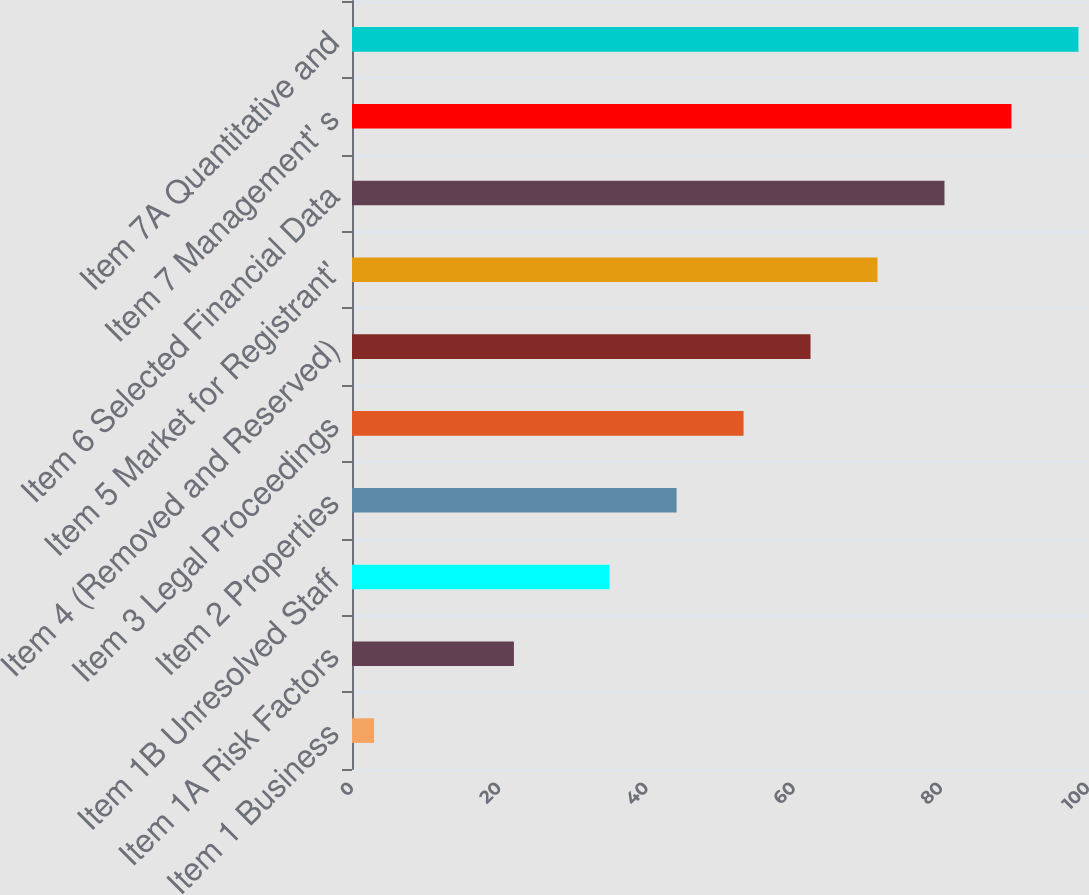Convert chart. <chart><loc_0><loc_0><loc_500><loc_500><bar_chart><fcel>Item 1 Business<fcel>Item 1A Risk Factors<fcel>Item 1B Unresolved Staff<fcel>Item 2 Properties<fcel>Item 3 Legal Proceedings<fcel>Item 4 (Removed and Reserved)<fcel>Item 5 Market for Registrant'<fcel>Item 6 Selected Financial Data<fcel>Item 7 Management' s<fcel>Item 7A Quantitative and<nl><fcel>3<fcel>22<fcel>35<fcel>44.1<fcel>53.2<fcel>62.3<fcel>71.4<fcel>80.5<fcel>89.6<fcel>98.7<nl></chart> 